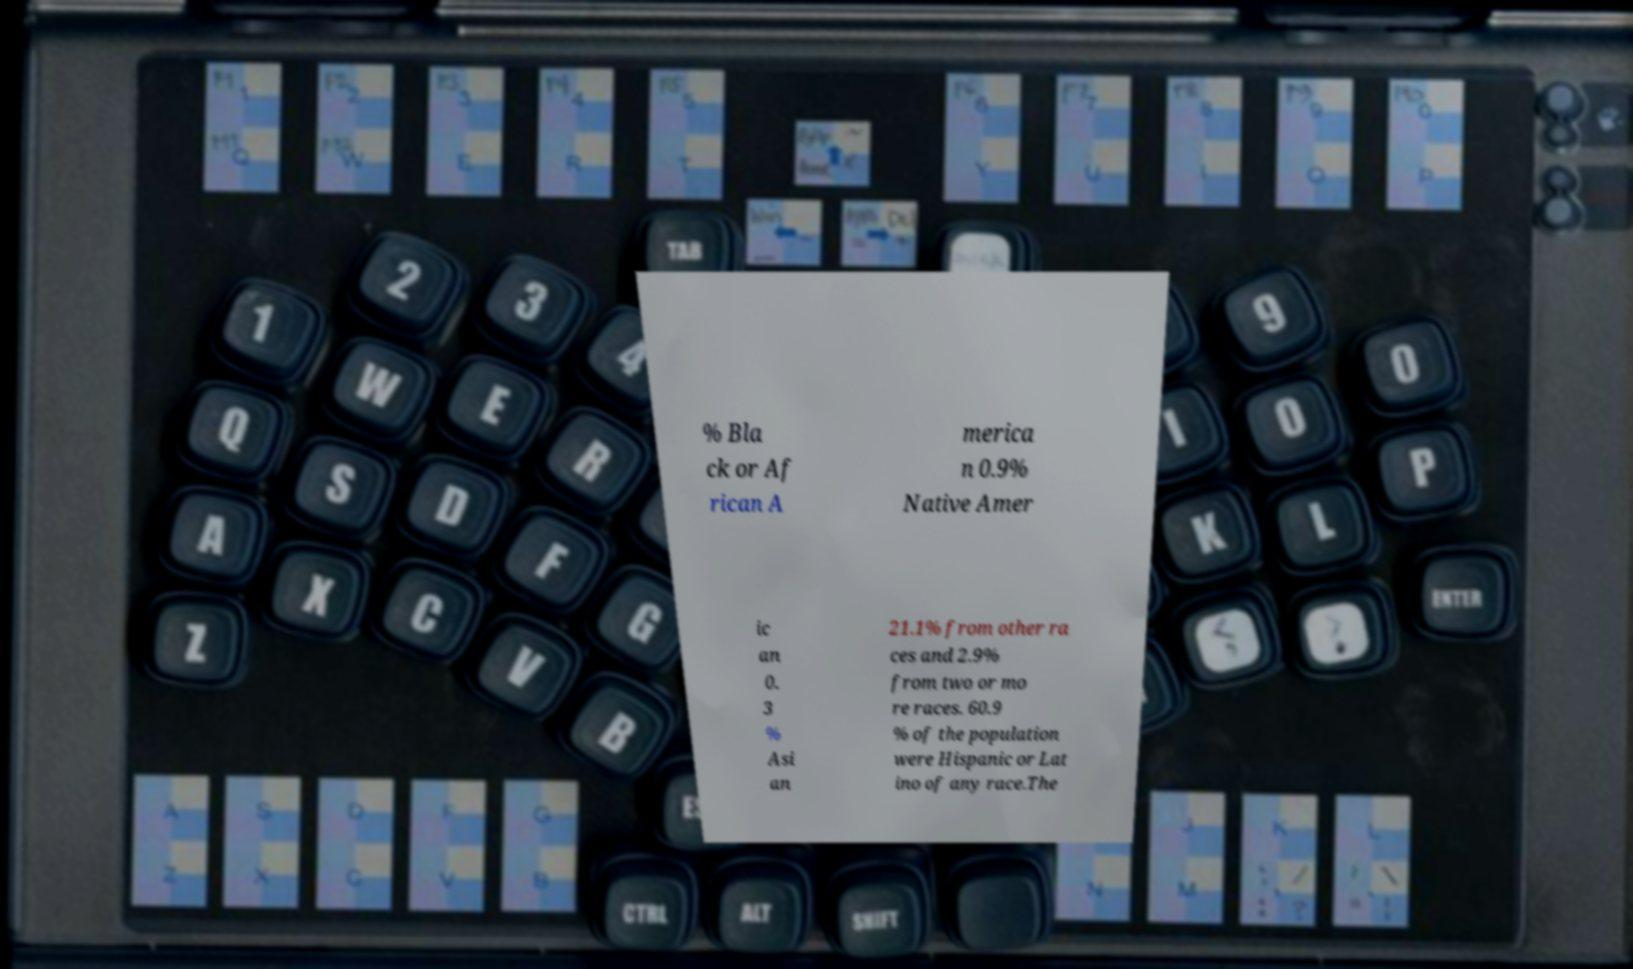Please read and relay the text visible in this image. What does it say? % Bla ck or Af rican A merica n 0.9% Native Amer ic an 0. 3 % Asi an 21.1% from other ra ces and 2.9% from two or mo re races. 60.9 % of the population were Hispanic or Lat ino of any race.The 